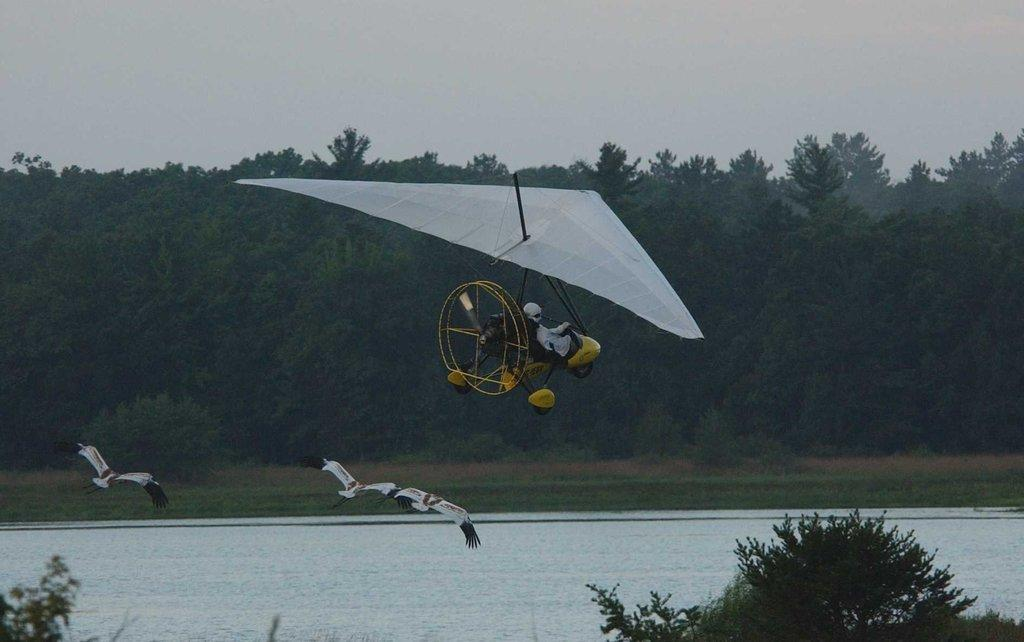What is the object in the air that a person is sitting in? The object in the air is not specified, but a person is sitting in it. What can be seen in the sky in the image? Flying birds are visible in the image. What type of natural environment is present in the image? There are trees and water visible in the image. What type of road can be seen in the image? There is no road visible in the image; it features an object in the air, a person sitting in it, flying birds, trees, and water. 